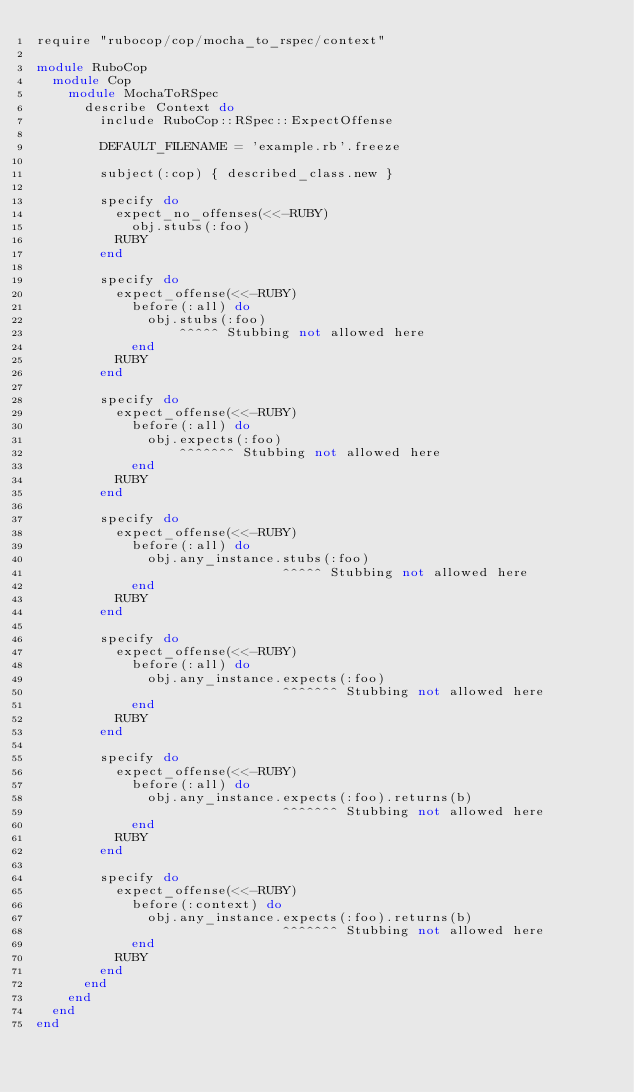<code> <loc_0><loc_0><loc_500><loc_500><_Ruby_>require "rubocop/cop/mocha_to_rspec/context"

module RuboCop
  module Cop
    module MochaToRSpec
      describe Context do
        include RuboCop::RSpec::ExpectOffense

        DEFAULT_FILENAME = 'example.rb'.freeze

        subject(:cop) { described_class.new }

        specify do
          expect_no_offenses(<<-RUBY)
            obj.stubs(:foo)
          RUBY
        end

        specify do
          expect_offense(<<-RUBY)
            before(:all) do
              obj.stubs(:foo)
                  ^^^^^ Stubbing not allowed here
            end
          RUBY
        end

        specify do
          expect_offense(<<-RUBY)
            before(:all) do
              obj.expects(:foo)
                  ^^^^^^^ Stubbing not allowed here
            end
          RUBY
        end

        specify do
          expect_offense(<<-RUBY)
            before(:all) do
              obj.any_instance.stubs(:foo)
                               ^^^^^ Stubbing not allowed here
            end
          RUBY
        end

        specify do
          expect_offense(<<-RUBY)
            before(:all) do
              obj.any_instance.expects(:foo)
                               ^^^^^^^ Stubbing not allowed here
            end
          RUBY
        end

        specify do
          expect_offense(<<-RUBY)
            before(:all) do
              obj.any_instance.expects(:foo).returns(b)
                               ^^^^^^^ Stubbing not allowed here
            end
          RUBY
        end

        specify do
          expect_offense(<<-RUBY)
            before(:context) do
              obj.any_instance.expects(:foo).returns(b)
                               ^^^^^^^ Stubbing not allowed here
            end
          RUBY
        end
      end
    end
  end
end
</code> 